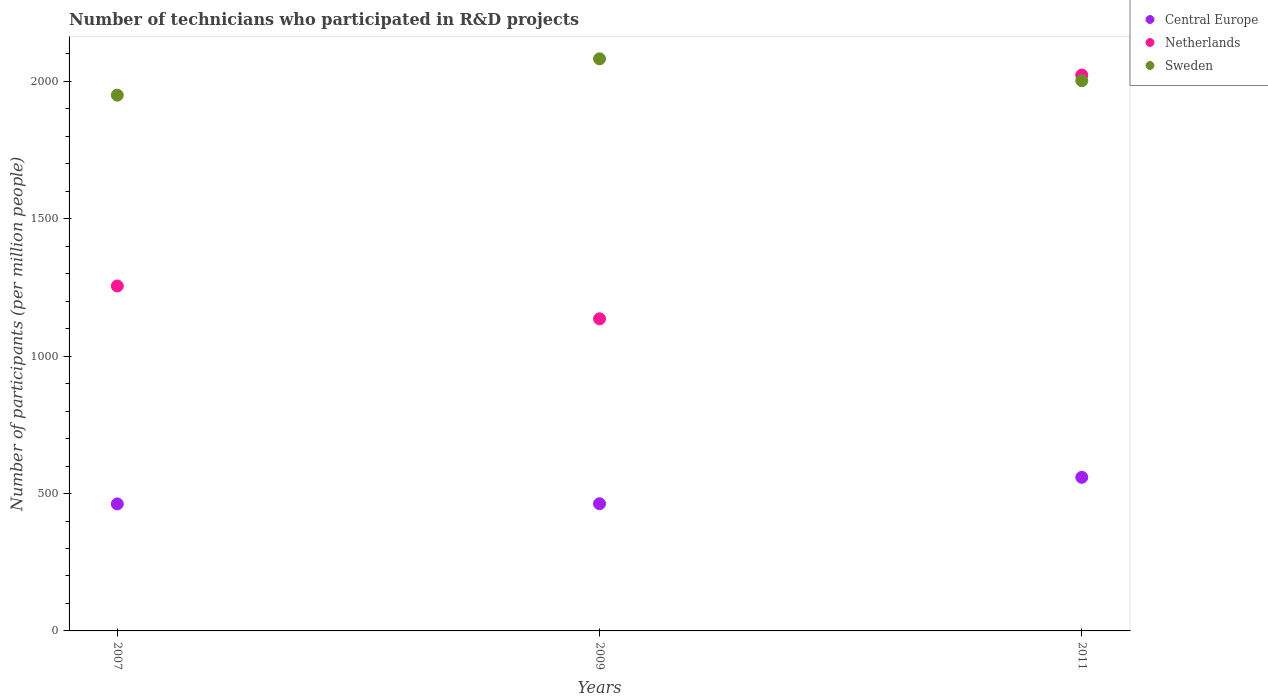How many different coloured dotlines are there?
Offer a terse response. 3. What is the number of technicians who participated in R&D projects in Sweden in 2007?
Provide a succinct answer. 1950. Across all years, what is the maximum number of technicians who participated in R&D projects in Netherlands?
Give a very brief answer. 2023.31. Across all years, what is the minimum number of technicians who participated in R&D projects in Sweden?
Offer a very short reply. 1950. What is the total number of technicians who participated in R&D projects in Central Europe in the graph?
Keep it short and to the point. 1484.38. What is the difference between the number of technicians who participated in R&D projects in Central Europe in 2007 and that in 2011?
Your answer should be compact. -96.82. What is the difference between the number of technicians who participated in R&D projects in Sweden in 2007 and the number of technicians who participated in R&D projects in Netherlands in 2009?
Your answer should be very brief. 814.03. What is the average number of technicians who participated in R&D projects in Sweden per year?
Ensure brevity in your answer.  2011.6. In the year 2007, what is the difference between the number of technicians who participated in R&D projects in Sweden and number of technicians who participated in R&D projects in Central Europe?
Offer a very short reply. 1487.73. What is the ratio of the number of technicians who participated in R&D projects in Central Europe in 2007 to that in 2009?
Offer a very short reply. 1. Is the difference between the number of technicians who participated in R&D projects in Sweden in 2009 and 2011 greater than the difference between the number of technicians who participated in R&D projects in Central Europe in 2009 and 2011?
Keep it short and to the point. Yes. What is the difference between the highest and the second highest number of technicians who participated in R&D projects in Netherlands?
Offer a very short reply. 767.83. What is the difference between the highest and the lowest number of technicians who participated in R&D projects in Central Europe?
Give a very brief answer. 96.82. Is the number of technicians who participated in R&D projects in Central Europe strictly less than the number of technicians who participated in R&D projects in Netherlands over the years?
Provide a short and direct response. Yes. How many dotlines are there?
Your answer should be very brief. 3. How many years are there in the graph?
Your answer should be compact. 3. Does the graph contain any zero values?
Offer a terse response. No. Where does the legend appear in the graph?
Ensure brevity in your answer.  Top right. How are the legend labels stacked?
Keep it short and to the point. Vertical. What is the title of the graph?
Offer a terse response. Number of technicians who participated in R&D projects. Does "Denmark" appear as one of the legend labels in the graph?
Provide a succinct answer. No. What is the label or title of the X-axis?
Your response must be concise. Years. What is the label or title of the Y-axis?
Make the answer very short. Number of participants (per million people). What is the Number of participants (per million people) of Central Europe in 2007?
Give a very brief answer. 462.27. What is the Number of participants (per million people) in Netherlands in 2007?
Provide a succinct answer. 1255.48. What is the Number of participants (per million people) of Sweden in 2007?
Keep it short and to the point. 1950. What is the Number of participants (per million people) of Central Europe in 2009?
Your response must be concise. 463.02. What is the Number of participants (per million people) in Netherlands in 2009?
Provide a short and direct response. 1135.98. What is the Number of participants (per million people) of Sweden in 2009?
Your answer should be compact. 2082.24. What is the Number of participants (per million people) of Central Europe in 2011?
Offer a terse response. 559.09. What is the Number of participants (per million people) in Netherlands in 2011?
Provide a succinct answer. 2023.31. What is the Number of participants (per million people) of Sweden in 2011?
Provide a succinct answer. 2002.57. Across all years, what is the maximum Number of participants (per million people) of Central Europe?
Make the answer very short. 559.09. Across all years, what is the maximum Number of participants (per million people) in Netherlands?
Provide a succinct answer. 2023.31. Across all years, what is the maximum Number of participants (per million people) in Sweden?
Ensure brevity in your answer.  2082.24. Across all years, what is the minimum Number of participants (per million people) of Central Europe?
Provide a succinct answer. 462.27. Across all years, what is the minimum Number of participants (per million people) in Netherlands?
Your answer should be compact. 1135.98. Across all years, what is the minimum Number of participants (per million people) of Sweden?
Offer a very short reply. 1950. What is the total Number of participants (per million people) in Central Europe in the graph?
Ensure brevity in your answer.  1484.38. What is the total Number of participants (per million people) of Netherlands in the graph?
Make the answer very short. 4414.76. What is the total Number of participants (per million people) in Sweden in the graph?
Offer a terse response. 6034.81. What is the difference between the Number of participants (per million people) in Central Europe in 2007 and that in 2009?
Offer a very short reply. -0.75. What is the difference between the Number of participants (per million people) of Netherlands in 2007 and that in 2009?
Give a very brief answer. 119.5. What is the difference between the Number of participants (per million people) in Sweden in 2007 and that in 2009?
Your answer should be compact. -132.24. What is the difference between the Number of participants (per million people) of Central Europe in 2007 and that in 2011?
Provide a succinct answer. -96.82. What is the difference between the Number of participants (per million people) of Netherlands in 2007 and that in 2011?
Offer a very short reply. -767.83. What is the difference between the Number of participants (per million people) of Sweden in 2007 and that in 2011?
Offer a terse response. -52.56. What is the difference between the Number of participants (per million people) of Central Europe in 2009 and that in 2011?
Offer a very short reply. -96.07. What is the difference between the Number of participants (per million people) in Netherlands in 2009 and that in 2011?
Make the answer very short. -887.33. What is the difference between the Number of participants (per million people) in Sweden in 2009 and that in 2011?
Offer a terse response. 79.67. What is the difference between the Number of participants (per million people) of Central Europe in 2007 and the Number of participants (per million people) of Netherlands in 2009?
Provide a short and direct response. -673.7. What is the difference between the Number of participants (per million people) of Central Europe in 2007 and the Number of participants (per million people) of Sweden in 2009?
Keep it short and to the point. -1619.97. What is the difference between the Number of participants (per million people) of Netherlands in 2007 and the Number of participants (per million people) of Sweden in 2009?
Keep it short and to the point. -826.76. What is the difference between the Number of participants (per million people) in Central Europe in 2007 and the Number of participants (per million people) in Netherlands in 2011?
Your response must be concise. -1561.03. What is the difference between the Number of participants (per million people) in Central Europe in 2007 and the Number of participants (per million people) in Sweden in 2011?
Make the answer very short. -1540.29. What is the difference between the Number of participants (per million people) in Netherlands in 2007 and the Number of participants (per million people) in Sweden in 2011?
Your response must be concise. -747.09. What is the difference between the Number of participants (per million people) of Central Europe in 2009 and the Number of participants (per million people) of Netherlands in 2011?
Keep it short and to the point. -1560.28. What is the difference between the Number of participants (per million people) of Central Europe in 2009 and the Number of participants (per million people) of Sweden in 2011?
Your response must be concise. -1539.55. What is the difference between the Number of participants (per million people) in Netherlands in 2009 and the Number of participants (per million people) in Sweden in 2011?
Give a very brief answer. -866.59. What is the average Number of participants (per million people) of Central Europe per year?
Offer a terse response. 494.79. What is the average Number of participants (per million people) in Netherlands per year?
Offer a very short reply. 1471.59. What is the average Number of participants (per million people) in Sweden per year?
Your answer should be compact. 2011.6. In the year 2007, what is the difference between the Number of participants (per million people) in Central Europe and Number of participants (per million people) in Netherlands?
Your answer should be very brief. -793.21. In the year 2007, what is the difference between the Number of participants (per million people) of Central Europe and Number of participants (per million people) of Sweden?
Your answer should be compact. -1487.73. In the year 2007, what is the difference between the Number of participants (per million people) in Netherlands and Number of participants (per million people) in Sweden?
Make the answer very short. -694.52. In the year 2009, what is the difference between the Number of participants (per million people) in Central Europe and Number of participants (per million people) in Netherlands?
Your response must be concise. -672.95. In the year 2009, what is the difference between the Number of participants (per million people) in Central Europe and Number of participants (per million people) in Sweden?
Your answer should be compact. -1619.22. In the year 2009, what is the difference between the Number of participants (per million people) of Netherlands and Number of participants (per million people) of Sweden?
Keep it short and to the point. -946.27. In the year 2011, what is the difference between the Number of participants (per million people) of Central Europe and Number of participants (per million people) of Netherlands?
Your response must be concise. -1464.22. In the year 2011, what is the difference between the Number of participants (per million people) of Central Europe and Number of participants (per million people) of Sweden?
Offer a terse response. -1443.48. In the year 2011, what is the difference between the Number of participants (per million people) of Netherlands and Number of participants (per million people) of Sweden?
Provide a succinct answer. 20.74. What is the ratio of the Number of participants (per million people) in Netherlands in 2007 to that in 2009?
Your answer should be very brief. 1.11. What is the ratio of the Number of participants (per million people) of Sweden in 2007 to that in 2009?
Offer a very short reply. 0.94. What is the ratio of the Number of participants (per million people) of Central Europe in 2007 to that in 2011?
Keep it short and to the point. 0.83. What is the ratio of the Number of participants (per million people) in Netherlands in 2007 to that in 2011?
Your response must be concise. 0.62. What is the ratio of the Number of participants (per million people) of Sweden in 2007 to that in 2011?
Your response must be concise. 0.97. What is the ratio of the Number of participants (per million people) in Central Europe in 2009 to that in 2011?
Provide a short and direct response. 0.83. What is the ratio of the Number of participants (per million people) in Netherlands in 2009 to that in 2011?
Ensure brevity in your answer.  0.56. What is the ratio of the Number of participants (per million people) in Sweden in 2009 to that in 2011?
Your answer should be compact. 1.04. What is the difference between the highest and the second highest Number of participants (per million people) of Central Europe?
Provide a short and direct response. 96.07. What is the difference between the highest and the second highest Number of participants (per million people) in Netherlands?
Your response must be concise. 767.83. What is the difference between the highest and the second highest Number of participants (per million people) of Sweden?
Offer a terse response. 79.67. What is the difference between the highest and the lowest Number of participants (per million people) of Central Europe?
Your answer should be very brief. 96.82. What is the difference between the highest and the lowest Number of participants (per million people) of Netherlands?
Give a very brief answer. 887.33. What is the difference between the highest and the lowest Number of participants (per million people) in Sweden?
Your answer should be compact. 132.24. 